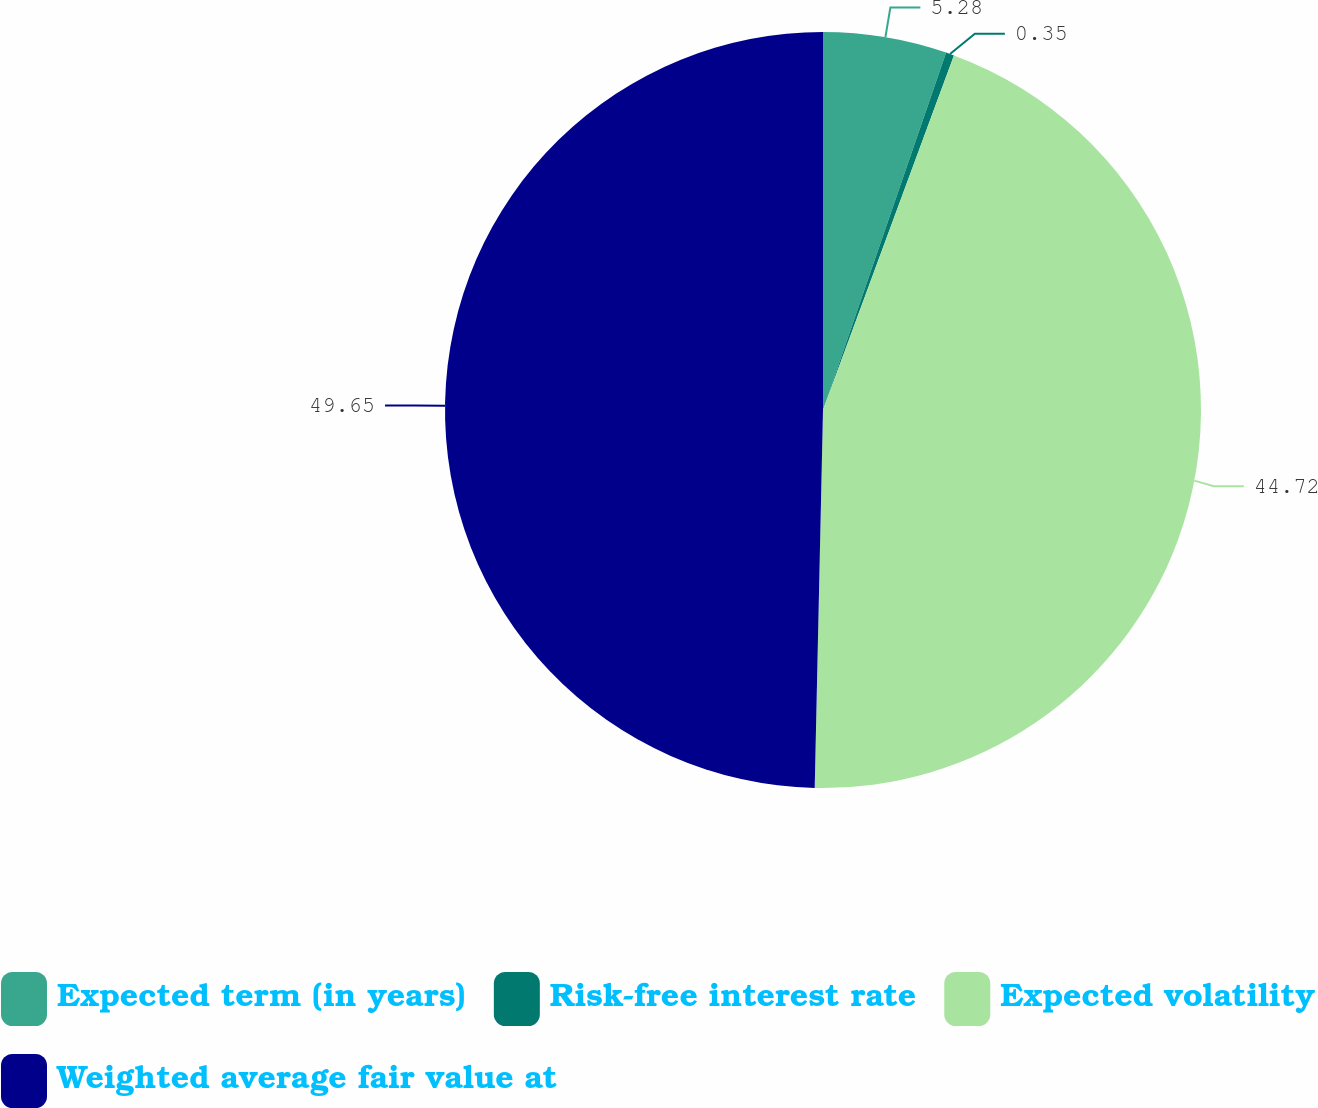<chart> <loc_0><loc_0><loc_500><loc_500><pie_chart><fcel>Expected term (in years)<fcel>Risk-free interest rate<fcel>Expected volatility<fcel>Weighted average fair value at<nl><fcel>5.28%<fcel>0.35%<fcel>44.72%<fcel>49.65%<nl></chart> 